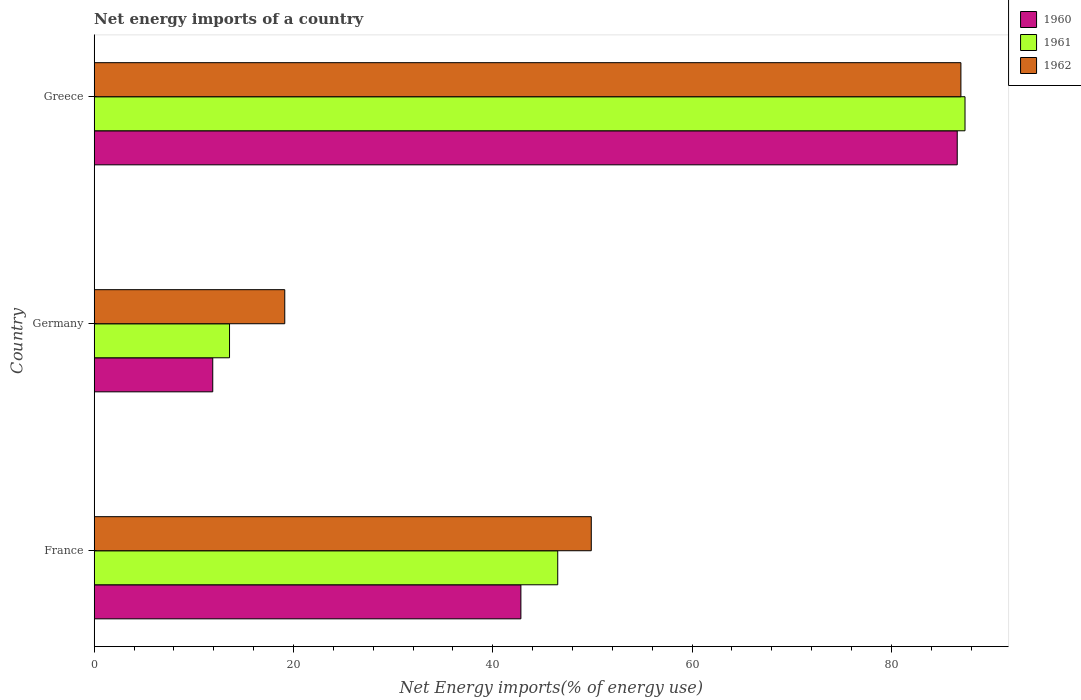How many groups of bars are there?
Offer a very short reply. 3. Are the number of bars on each tick of the Y-axis equal?
Your answer should be very brief. Yes. How many bars are there on the 2nd tick from the top?
Offer a terse response. 3. In how many cases, is the number of bars for a given country not equal to the number of legend labels?
Provide a succinct answer. 0. What is the net energy imports in 1962 in France?
Offer a very short reply. 49.89. Across all countries, what is the maximum net energy imports in 1962?
Make the answer very short. 86.98. Across all countries, what is the minimum net energy imports in 1962?
Offer a very short reply. 19.13. What is the total net energy imports in 1962 in the graph?
Ensure brevity in your answer.  156. What is the difference between the net energy imports in 1960 in France and that in Germany?
Make the answer very short. 30.93. What is the difference between the net energy imports in 1960 in Greece and the net energy imports in 1962 in France?
Keep it short and to the point. 36.73. What is the average net energy imports in 1960 per country?
Offer a very short reply. 47.11. What is the difference between the net energy imports in 1962 and net energy imports in 1960 in Greece?
Provide a succinct answer. 0.37. In how many countries, is the net energy imports in 1962 greater than 56 %?
Give a very brief answer. 1. What is the ratio of the net energy imports in 1961 in France to that in Greece?
Your answer should be compact. 0.53. What is the difference between the highest and the second highest net energy imports in 1960?
Give a very brief answer. 43.79. What is the difference between the highest and the lowest net energy imports in 1962?
Make the answer very short. 67.86. Is it the case that in every country, the sum of the net energy imports in 1960 and net energy imports in 1961 is greater than the net energy imports in 1962?
Keep it short and to the point. Yes. How many bars are there?
Provide a short and direct response. 9. How many countries are there in the graph?
Your response must be concise. 3. Are the values on the major ticks of X-axis written in scientific E-notation?
Keep it short and to the point. No. Does the graph contain grids?
Keep it short and to the point. No. Where does the legend appear in the graph?
Provide a succinct answer. Top right. How many legend labels are there?
Give a very brief answer. 3. How are the legend labels stacked?
Your answer should be very brief. Vertical. What is the title of the graph?
Give a very brief answer. Net energy imports of a country. Does "2013" appear as one of the legend labels in the graph?
Make the answer very short. No. What is the label or title of the X-axis?
Provide a short and direct response. Net Energy imports(% of energy use). What is the label or title of the Y-axis?
Make the answer very short. Country. What is the Net Energy imports(% of energy use) of 1960 in France?
Ensure brevity in your answer.  42.82. What is the Net Energy imports(% of energy use) of 1961 in France?
Offer a terse response. 46.52. What is the Net Energy imports(% of energy use) in 1962 in France?
Offer a very short reply. 49.89. What is the Net Energy imports(% of energy use) of 1960 in Germany?
Offer a terse response. 11.9. What is the Net Energy imports(% of energy use) in 1961 in Germany?
Provide a succinct answer. 13.58. What is the Net Energy imports(% of energy use) in 1962 in Germany?
Provide a short and direct response. 19.13. What is the Net Energy imports(% of energy use) in 1960 in Greece?
Give a very brief answer. 86.62. What is the Net Energy imports(% of energy use) in 1961 in Greece?
Keep it short and to the point. 87.4. What is the Net Energy imports(% of energy use) in 1962 in Greece?
Make the answer very short. 86.98. Across all countries, what is the maximum Net Energy imports(% of energy use) in 1960?
Your response must be concise. 86.62. Across all countries, what is the maximum Net Energy imports(% of energy use) in 1961?
Your response must be concise. 87.4. Across all countries, what is the maximum Net Energy imports(% of energy use) in 1962?
Your answer should be compact. 86.98. Across all countries, what is the minimum Net Energy imports(% of energy use) of 1960?
Provide a short and direct response. 11.9. Across all countries, what is the minimum Net Energy imports(% of energy use) in 1961?
Ensure brevity in your answer.  13.58. Across all countries, what is the minimum Net Energy imports(% of energy use) in 1962?
Offer a terse response. 19.13. What is the total Net Energy imports(% of energy use) in 1960 in the graph?
Offer a terse response. 141.34. What is the total Net Energy imports(% of energy use) of 1961 in the graph?
Your answer should be compact. 147.5. What is the total Net Energy imports(% of energy use) in 1962 in the graph?
Your answer should be compact. 156. What is the difference between the Net Energy imports(% of energy use) of 1960 in France and that in Germany?
Your answer should be compact. 30.93. What is the difference between the Net Energy imports(% of energy use) of 1961 in France and that in Germany?
Your response must be concise. 32.94. What is the difference between the Net Energy imports(% of energy use) of 1962 in France and that in Germany?
Provide a succinct answer. 30.76. What is the difference between the Net Energy imports(% of energy use) in 1960 in France and that in Greece?
Offer a terse response. -43.79. What is the difference between the Net Energy imports(% of energy use) of 1961 in France and that in Greece?
Your answer should be very brief. -40.87. What is the difference between the Net Energy imports(% of energy use) of 1962 in France and that in Greece?
Your answer should be very brief. -37.09. What is the difference between the Net Energy imports(% of energy use) in 1960 in Germany and that in Greece?
Your answer should be compact. -74.72. What is the difference between the Net Energy imports(% of energy use) in 1961 in Germany and that in Greece?
Your response must be concise. -73.81. What is the difference between the Net Energy imports(% of energy use) in 1962 in Germany and that in Greece?
Make the answer very short. -67.86. What is the difference between the Net Energy imports(% of energy use) in 1960 in France and the Net Energy imports(% of energy use) in 1961 in Germany?
Give a very brief answer. 29.24. What is the difference between the Net Energy imports(% of energy use) of 1960 in France and the Net Energy imports(% of energy use) of 1962 in Germany?
Offer a very short reply. 23.7. What is the difference between the Net Energy imports(% of energy use) in 1961 in France and the Net Energy imports(% of energy use) in 1962 in Germany?
Your answer should be compact. 27.39. What is the difference between the Net Energy imports(% of energy use) of 1960 in France and the Net Energy imports(% of energy use) of 1961 in Greece?
Provide a short and direct response. -44.57. What is the difference between the Net Energy imports(% of energy use) of 1960 in France and the Net Energy imports(% of energy use) of 1962 in Greece?
Provide a short and direct response. -44.16. What is the difference between the Net Energy imports(% of energy use) of 1961 in France and the Net Energy imports(% of energy use) of 1962 in Greece?
Provide a short and direct response. -40.46. What is the difference between the Net Energy imports(% of energy use) of 1960 in Germany and the Net Energy imports(% of energy use) of 1961 in Greece?
Your answer should be compact. -75.5. What is the difference between the Net Energy imports(% of energy use) in 1960 in Germany and the Net Energy imports(% of energy use) in 1962 in Greece?
Provide a succinct answer. -75.08. What is the difference between the Net Energy imports(% of energy use) in 1961 in Germany and the Net Energy imports(% of energy use) in 1962 in Greece?
Offer a very short reply. -73.4. What is the average Net Energy imports(% of energy use) in 1960 per country?
Make the answer very short. 47.11. What is the average Net Energy imports(% of energy use) in 1961 per country?
Your response must be concise. 49.17. What is the average Net Energy imports(% of energy use) in 1962 per country?
Provide a succinct answer. 52. What is the difference between the Net Energy imports(% of energy use) of 1960 and Net Energy imports(% of energy use) of 1961 in France?
Keep it short and to the point. -3.7. What is the difference between the Net Energy imports(% of energy use) in 1960 and Net Energy imports(% of energy use) in 1962 in France?
Your answer should be very brief. -7.06. What is the difference between the Net Energy imports(% of energy use) of 1961 and Net Energy imports(% of energy use) of 1962 in France?
Provide a succinct answer. -3.37. What is the difference between the Net Energy imports(% of energy use) of 1960 and Net Energy imports(% of energy use) of 1961 in Germany?
Provide a short and direct response. -1.68. What is the difference between the Net Energy imports(% of energy use) of 1960 and Net Energy imports(% of energy use) of 1962 in Germany?
Provide a short and direct response. -7.23. What is the difference between the Net Energy imports(% of energy use) of 1961 and Net Energy imports(% of energy use) of 1962 in Germany?
Your response must be concise. -5.54. What is the difference between the Net Energy imports(% of energy use) in 1960 and Net Energy imports(% of energy use) in 1961 in Greece?
Your answer should be compact. -0.78. What is the difference between the Net Energy imports(% of energy use) in 1960 and Net Energy imports(% of energy use) in 1962 in Greece?
Give a very brief answer. -0.37. What is the difference between the Net Energy imports(% of energy use) in 1961 and Net Energy imports(% of energy use) in 1962 in Greece?
Offer a terse response. 0.41. What is the ratio of the Net Energy imports(% of energy use) in 1960 in France to that in Germany?
Give a very brief answer. 3.6. What is the ratio of the Net Energy imports(% of energy use) of 1961 in France to that in Germany?
Provide a short and direct response. 3.43. What is the ratio of the Net Energy imports(% of energy use) in 1962 in France to that in Germany?
Provide a short and direct response. 2.61. What is the ratio of the Net Energy imports(% of energy use) of 1960 in France to that in Greece?
Keep it short and to the point. 0.49. What is the ratio of the Net Energy imports(% of energy use) of 1961 in France to that in Greece?
Offer a very short reply. 0.53. What is the ratio of the Net Energy imports(% of energy use) of 1962 in France to that in Greece?
Ensure brevity in your answer.  0.57. What is the ratio of the Net Energy imports(% of energy use) in 1960 in Germany to that in Greece?
Your response must be concise. 0.14. What is the ratio of the Net Energy imports(% of energy use) of 1961 in Germany to that in Greece?
Your answer should be compact. 0.16. What is the ratio of the Net Energy imports(% of energy use) in 1962 in Germany to that in Greece?
Offer a terse response. 0.22. What is the difference between the highest and the second highest Net Energy imports(% of energy use) of 1960?
Provide a succinct answer. 43.79. What is the difference between the highest and the second highest Net Energy imports(% of energy use) of 1961?
Provide a succinct answer. 40.87. What is the difference between the highest and the second highest Net Energy imports(% of energy use) of 1962?
Your response must be concise. 37.09. What is the difference between the highest and the lowest Net Energy imports(% of energy use) in 1960?
Offer a terse response. 74.72. What is the difference between the highest and the lowest Net Energy imports(% of energy use) of 1961?
Give a very brief answer. 73.81. What is the difference between the highest and the lowest Net Energy imports(% of energy use) of 1962?
Offer a very short reply. 67.86. 